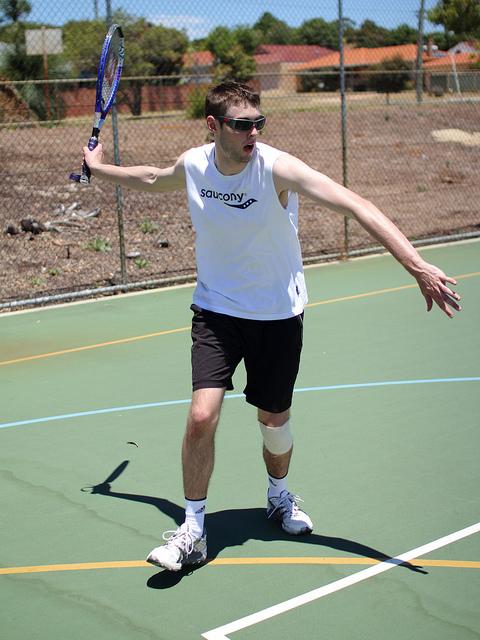What color are the man's shorts?
Be succinct. Black. What is the man holding?
Give a very brief answer. Tennis racket. Does the shirt have sleeves?
Give a very brief answer. No. 